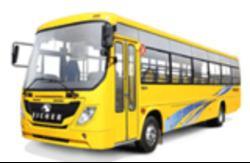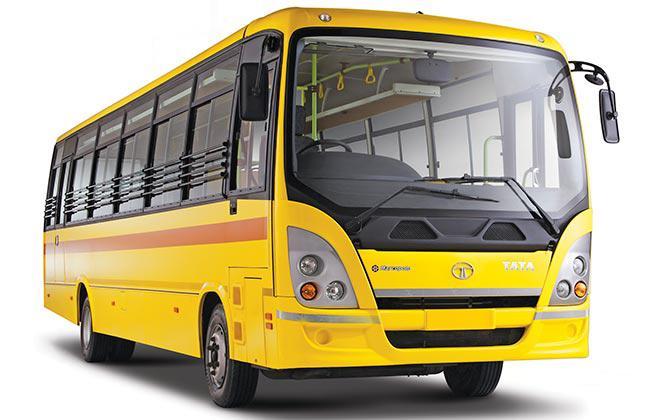The first image is the image on the left, the second image is the image on the right. Analyze the images presented: Is the assertion "The left and right image contains the same number of buses with one facing right forward and the other facing left forward." valid? Answer yes or no. Yes. The first image is the image on the left, the second image is the image on the right. Given the left and right images, does the statement "Each image shows the front of a flat-fronted bus, and the buses depicted on the left and right are angled in opposite directions." hold true? Answer yes or no. Yes. 